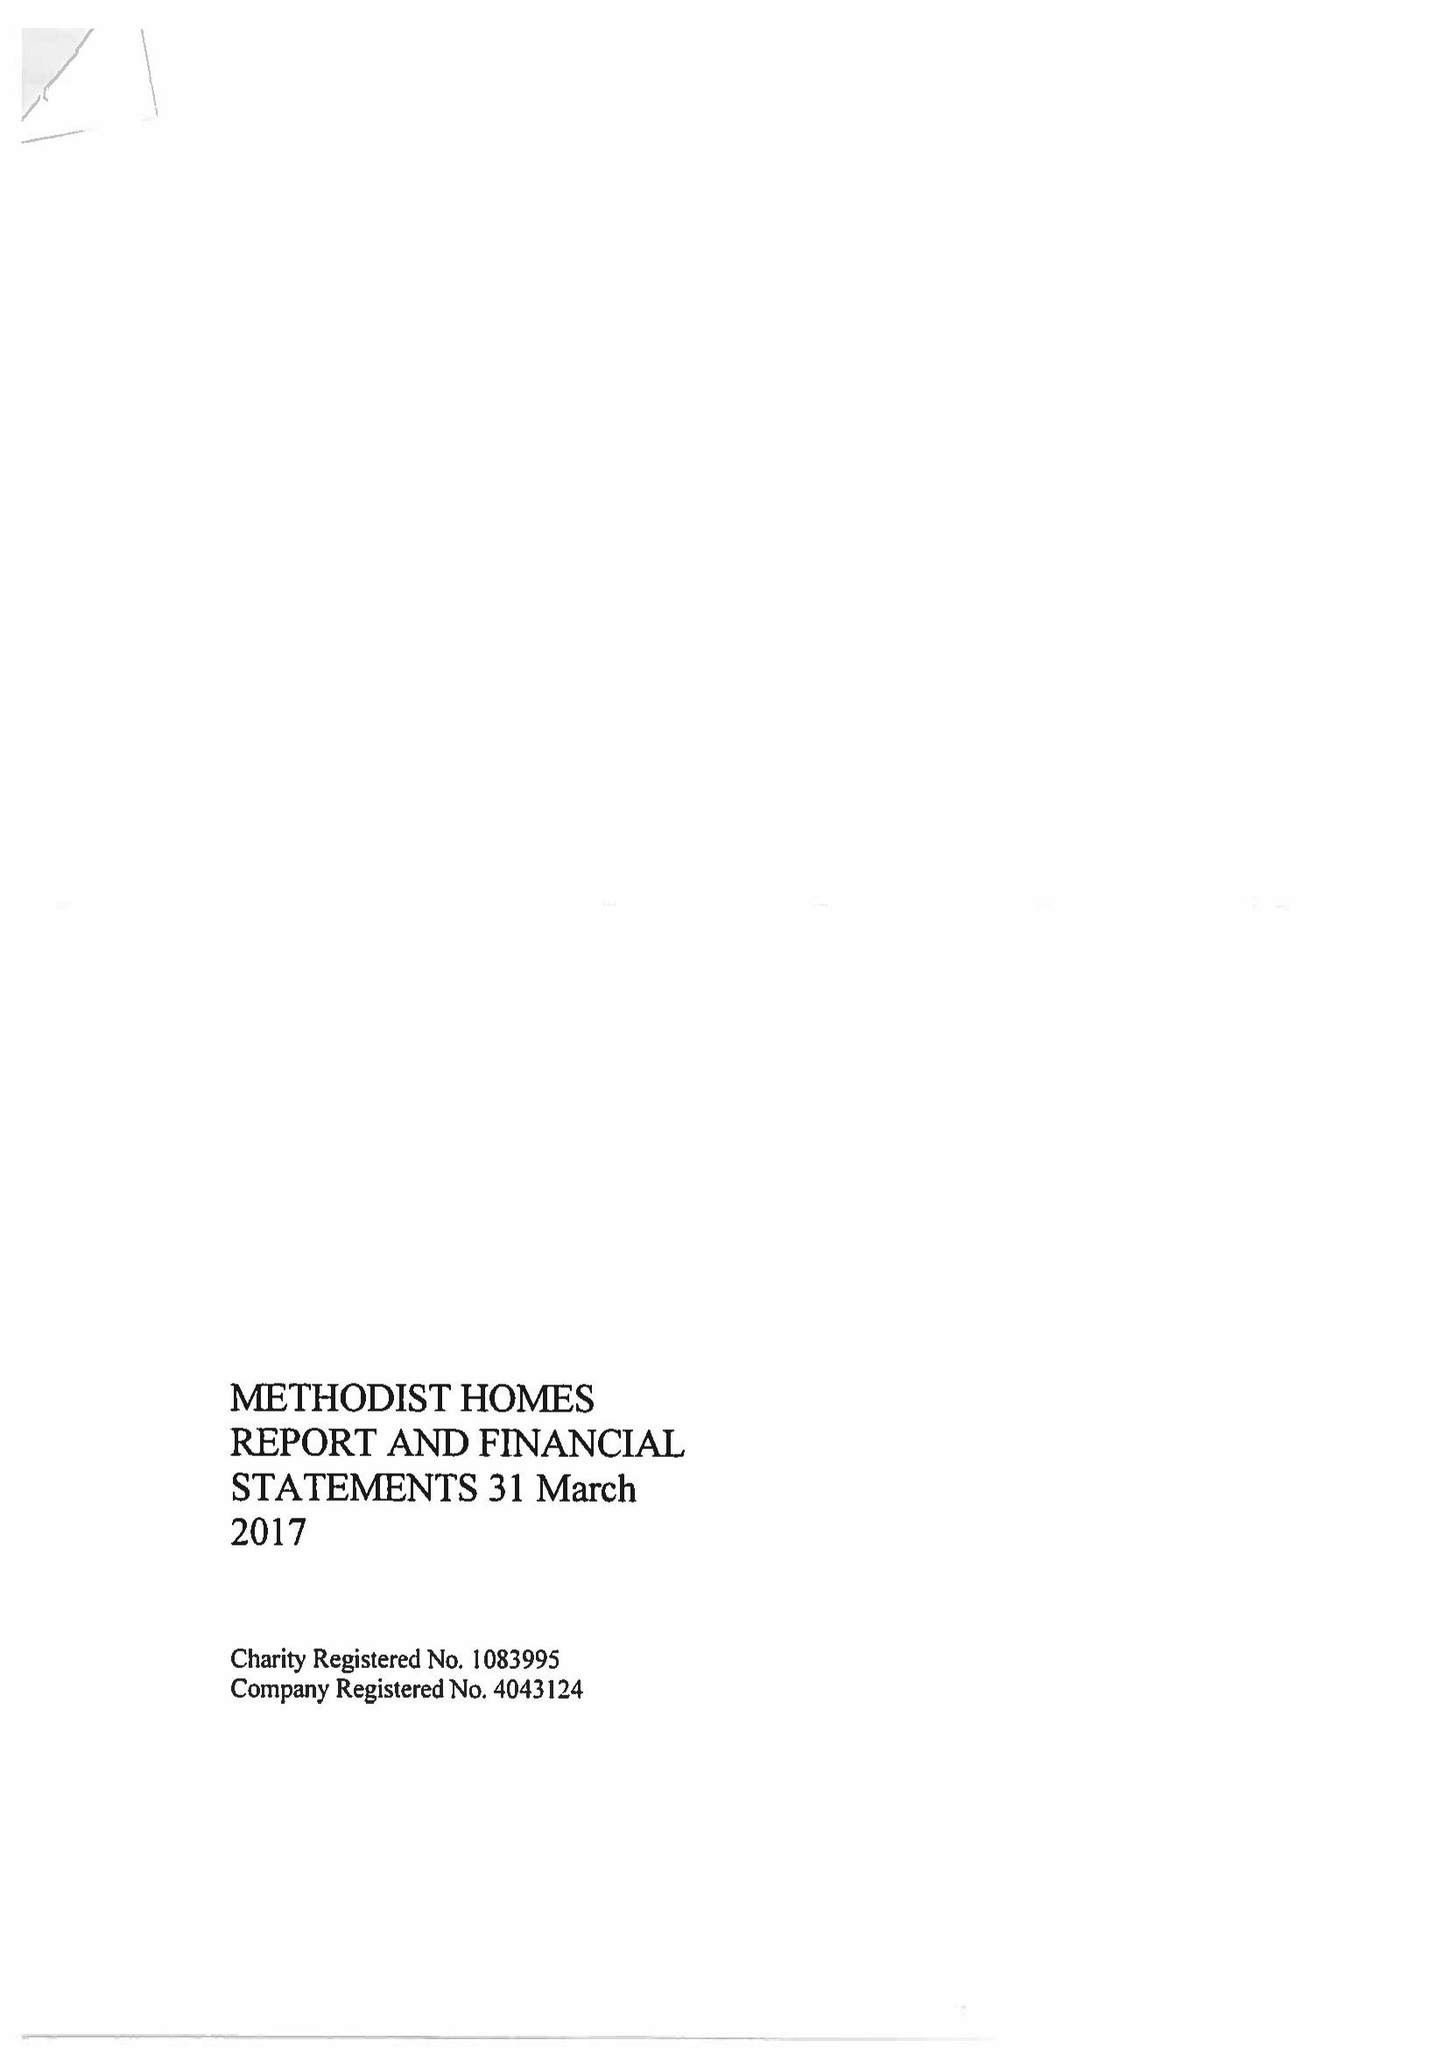What is the value for the address__postcode?
Answer the question using a single word or phrase. DE1 2EQ 